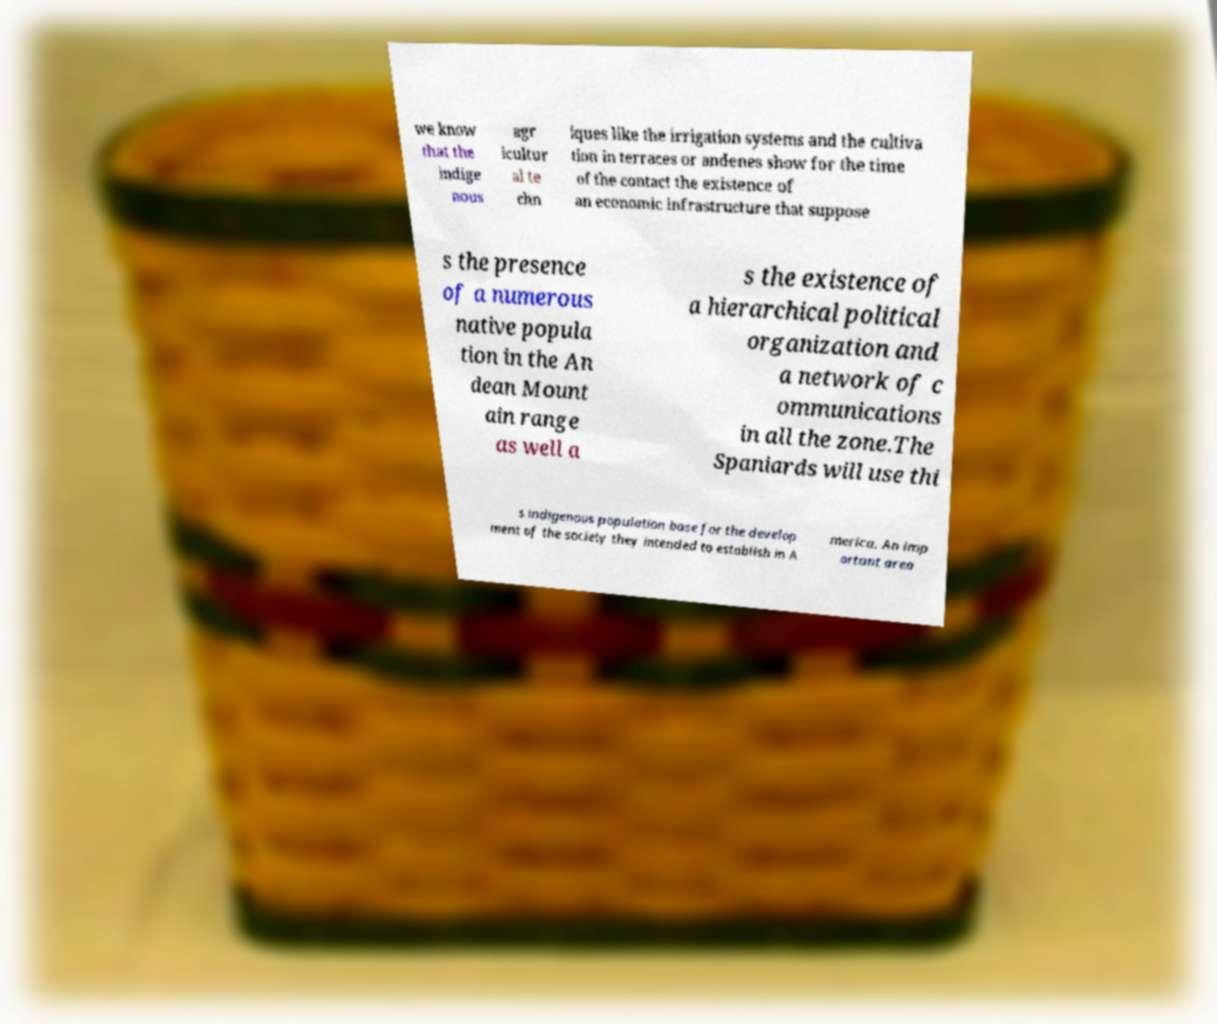There's text embedded in this image that I need extracted. Can you transcribe it verbatim? we know that the indige nous agr icultur al te chn iques like the irrigation systems and the cultiva tion in terraces or andenes show for the time of the contact the existence of an economic infrastructure that suppose s the presence of a numerous native popula tion in the An dean Mount ain range as well a s the existence of a hierarchical political organization and a network of c ommunications in all the zone.The Spaniards will use thi s indigenous population base for the develop ment of the society they intended to establish in A merica. An imp ortant area 